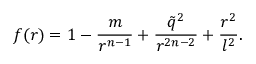Convert formula to latex. <formula><loc_0><loc_0><loc_500><loc_500>f ( r ) = 1 - \frac { m } { r ^ { n - 1 } } + \frac { \tilde { q } ^ { 2 } } { r ^ { 2 n - 2 } } + \frac { r ^ { 2 } } { l ^ { 2 } } .</formula> 